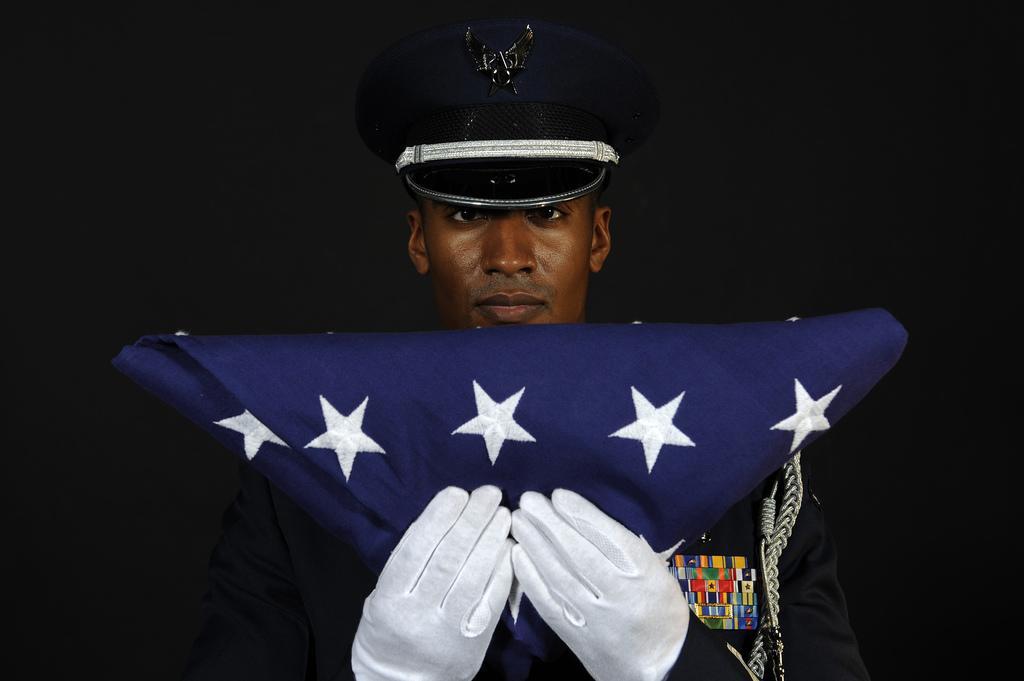How would you summarize this image in a sentence or two? In this image I can see a man wearing black color dress, white color gloves to the hands and holding a blue color cloth and looking at the picture. I can see a black color cap on his head. 